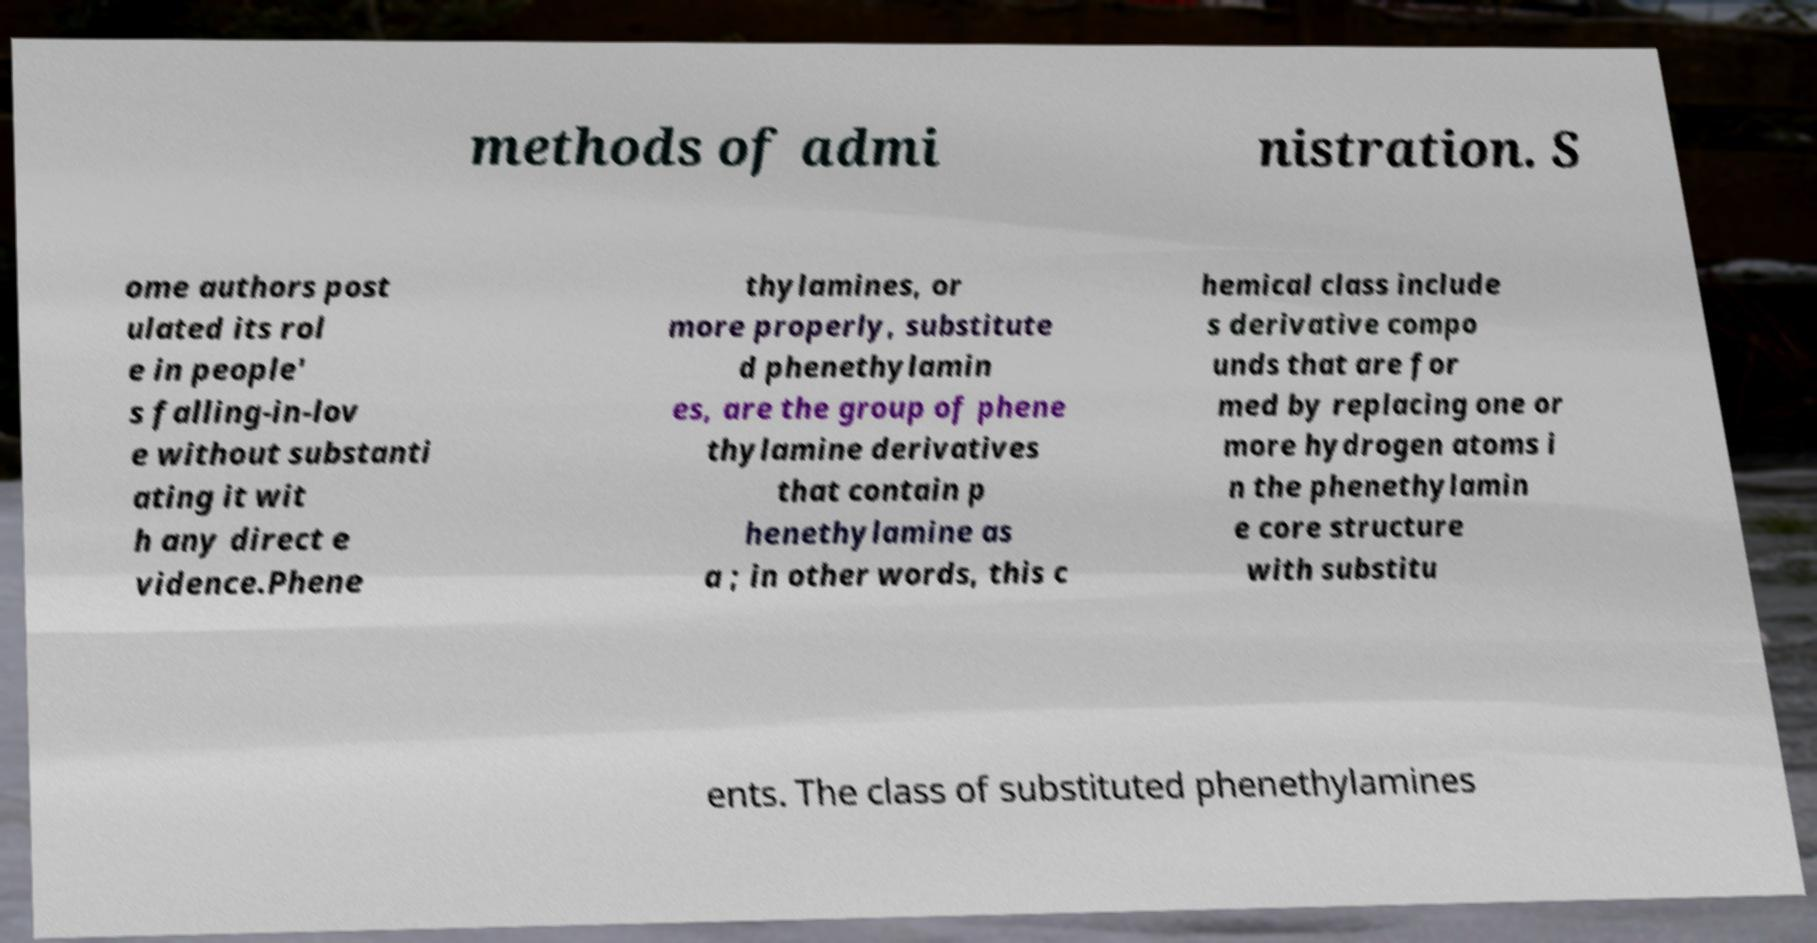I need the written content from this picture converted into text. Can you do that? methods of admi nistration. S ome authors post ulated its rol e in people' s falling-in-lov e without substanti ating it wit h any direct e vidence.Phene thylamines, or more properly, substitute d phenethylamin es, are the group of phene thylamine derivatives that contain p henethylamine as a ; in other words, this c hemical class include s derivative compo unds that are for med by replacing one or more hydrogen atoms i n the phenethylamin e core structure with substitu ents. The class of substituted phenethylamines 